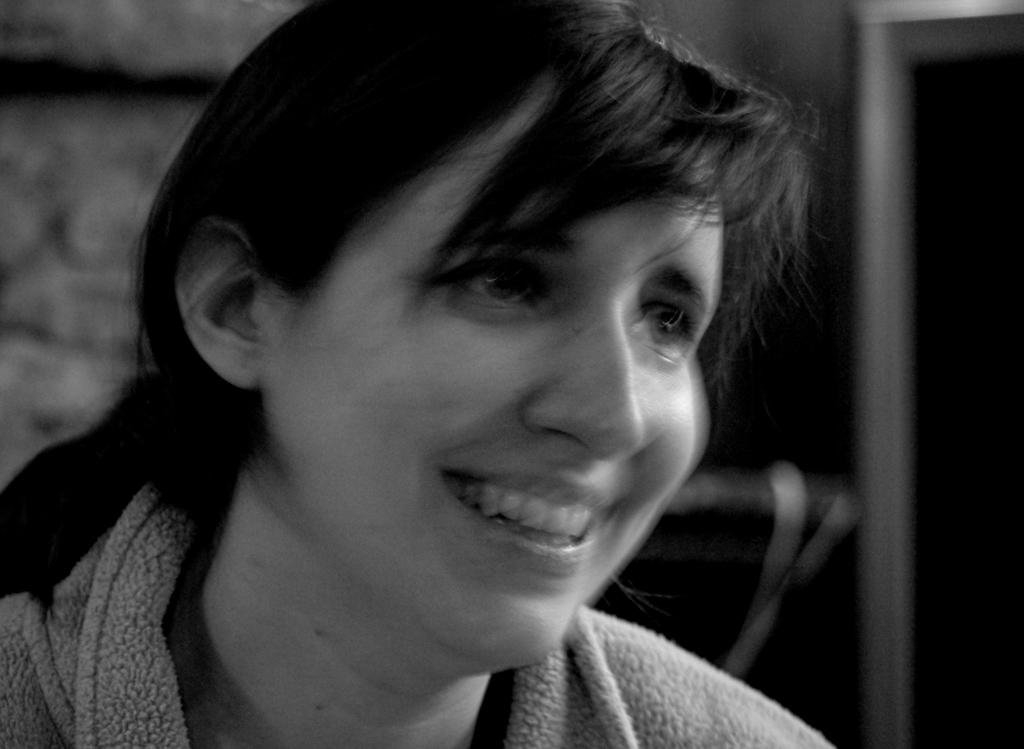What is the color scheme of the image? The image is black and white. Can you describe the background of the image? The background of the image is blurred. Who is the main subject in the image? There is a woman in the middle of the image. What is the facial expression of the woman? The woman has a smiling face. Can you see a giraffe in the background of the image? No, there is no giraffe present in the image. Is there a cat sitting next to the woman in the image? No, there is no cat present in the image. 